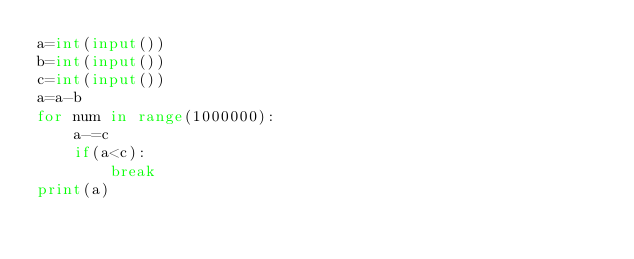<code> <loc_0><loc_0><loc_500><loc_500><_Python_>a=int(input())
b=int(input())
c=int(input())
a=a-b
for num in range(1000000):
    a-=c
    if(a<c):
        break
print(a)</code> 